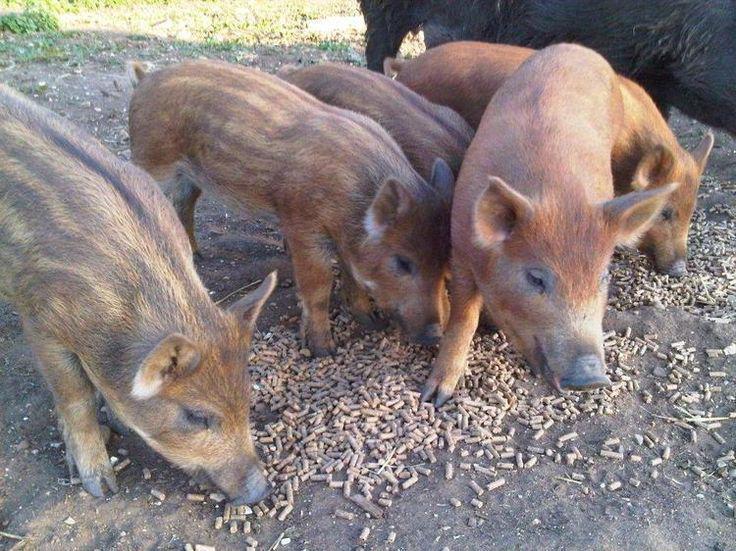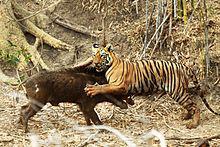The first image is the image on the left, the second image is the image on the right. For the images shown, is this caption "In one of the image there is a tiger attacking a pig." true? Answer yes or no. Yes. The first image is the image on the left, the second image is the image on the right. Examine the images to the left and right. Is the description "There is a tiger attacking a boar." accurate? Answer yes or no. Yes. 